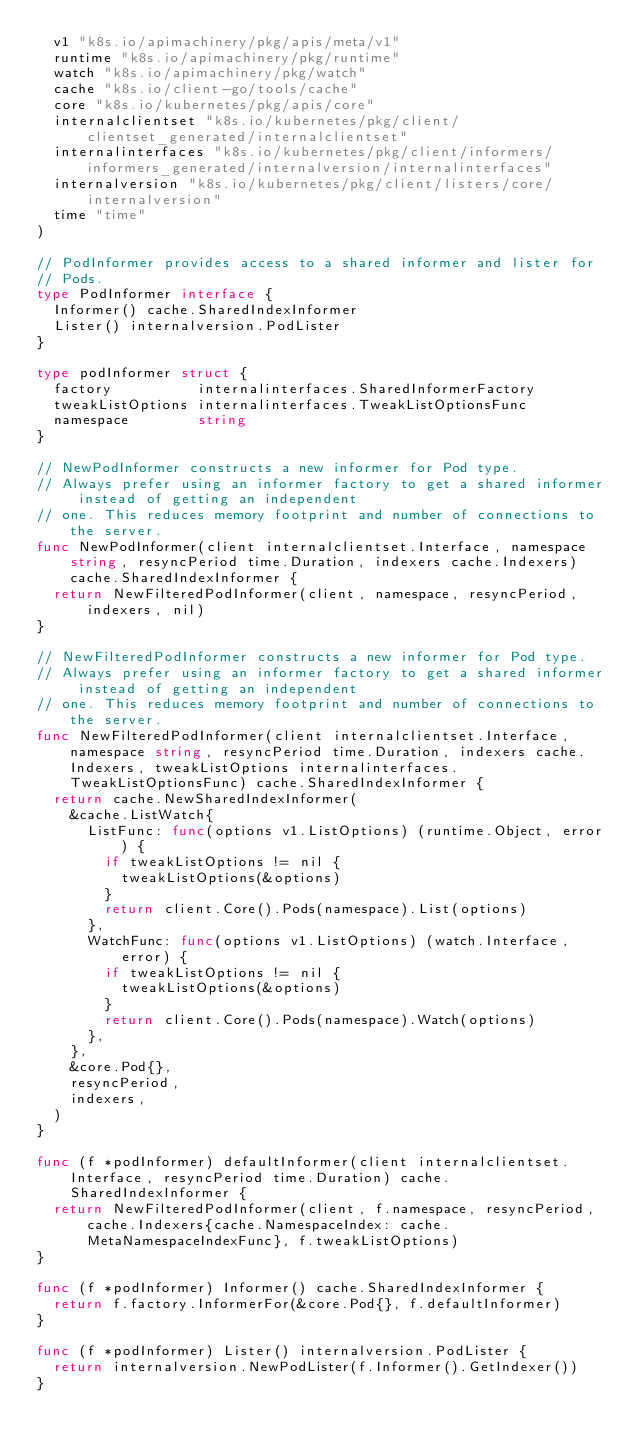Convert code to text. <code><loc_0><loc_0><loc_500><loc_500><_Go_>	v1 "k8s.io/apimachinery/pkg/apis/meta/v1"
	runtime "k8s.io/apimachinery/pkg/runtime"
	watch "k8s.io/apimachinery/pkg/watch"
	cache "k8s.io/client-go/tools/cache"
	core "k8s.io/kubernetes/pkg/apis/core"
	internalclientset "k8s.io/kubernetes/pkg/client/clientset_generated/internalclientset"
	internalinterfaces "k8s.io/kubernetes/pkg/client/informers/informers_generated/internalversion/internalinterfaces"
	internalversion "k8s.io/kubernetes/pkg/client/listers/core/internalversion"
	time "time"
)

// PodInformer provides access to a shared informer and lister for
// Pods.
type PodInformer interface {
	Informer() cache.SharedIndexInformer
	Lister() internalversion.PodLister
}

type podInformer struct {
	factory          internalinterfaces.SharedInformerFactory
	tweakListOptions internalinterfaces.TweakListOptionsFunc
	namespace        string
}

// NewPodInformer constructs a new informer for Pod type.
// Always prefer using an informer factory to get a shared informer instead of getting an independent
// one. This reduces memory footprint and number of connections to the server.
func NewPodInformer(client internalclientset.Interface, namespace string, resyncPeriod time.Duration, indexers cache.Indexers) cache.SharedIndexInformer {
	return NewFilteredPodInformer(client, namespace, resyncPeriod, indexers, nil)
}

// NewFilteredPodInformer constructs a new informer for Pod type.
// Always prefer using an informer factory to get a shared informer instead of getting an independent
// one. This reduces memory footprint and number of connections to the server.
func NewFilteredPodInformer(client internalclientset.Interface, namespace string, resyncPeriod time.Duration, indexers cache.Indexers, tweakListOptions internalinterfaces.TweakListOptionsFunc) cache.SharedIndexInformer {
	return cache.NewSharedIndexInformer(
		&cache.ListWatch{
			ListFunc: func(options v1.ListOptions) (runtime.Object, error) {
				if tweakListOptions != nil {
					tweakListOptions(&options)
				}
				return client.Core().Pods(namespace).List(options)
			},
			WatchFunc: func(options v1.ListOptions) (watch.Interface, error) {
				if tweakListOptions != nil {
					tweakListOptions(&options)
				}
				return client.Core().Pods(namespace).Watch(options)
			},
		},
		&core.Pod{},
		resyncPeriod,
		indexers,
	)
}

func (f *podInformer) defaultInformer(client internalclientset.Interface, resyncPeriod time.Duration) cache.SharedIndexInformer {
	return NewFilteredPodInformer(client, f.namespace, resyncPeriod, cache.Indexers{cache.NamespaceIndex: cache.MetaNamespaceIndexFunc}, f.tweakListOptions)
}

func (f *podInformer) Informer() cache.SharedIndexInformer {
	return f.factory.InformerFor(&core.Pod{}, f.defaultInformer)
}

func (f *podInformer) Lister() internalversion.PodLister {
	return internalversion.NewPodLister(f.Informer().GetIndexer())
}
</code> 